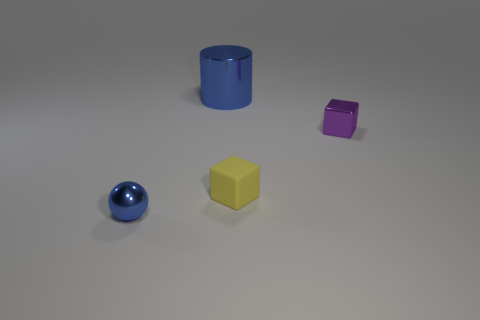Add 1 big yellow matte cubes. How many objects exist? 5 Subtract all red cylinders. How many red spheres are left? 0 Add 1 spheres. How many spheres exist? 2 Subtract all purple blocks. How many blocks are left? 1 Subtract 0 red cubes. How many objects are left? 4 Subtract all cylinders. How many objects are left? 3 Subtract 1 spheres. How many spheres are left? 0 Subtract all blue cubes. Subtract all yellow balls. How many cubes are left? 2 Subtract all large blue things. Subtract all large cylinders. How many objects are left? 2 Add 2 yellow cubes. How many yellow cubes are left? 3 